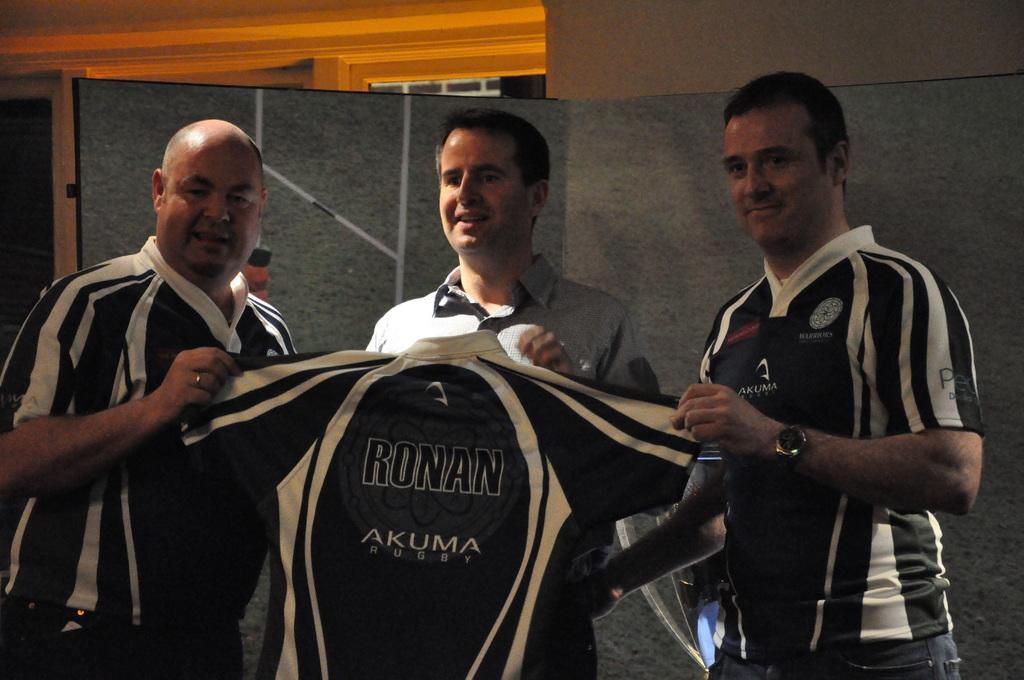<image>
Create a compact narrative representing the image presented. three men are holding a jersey with word Ronan on it 